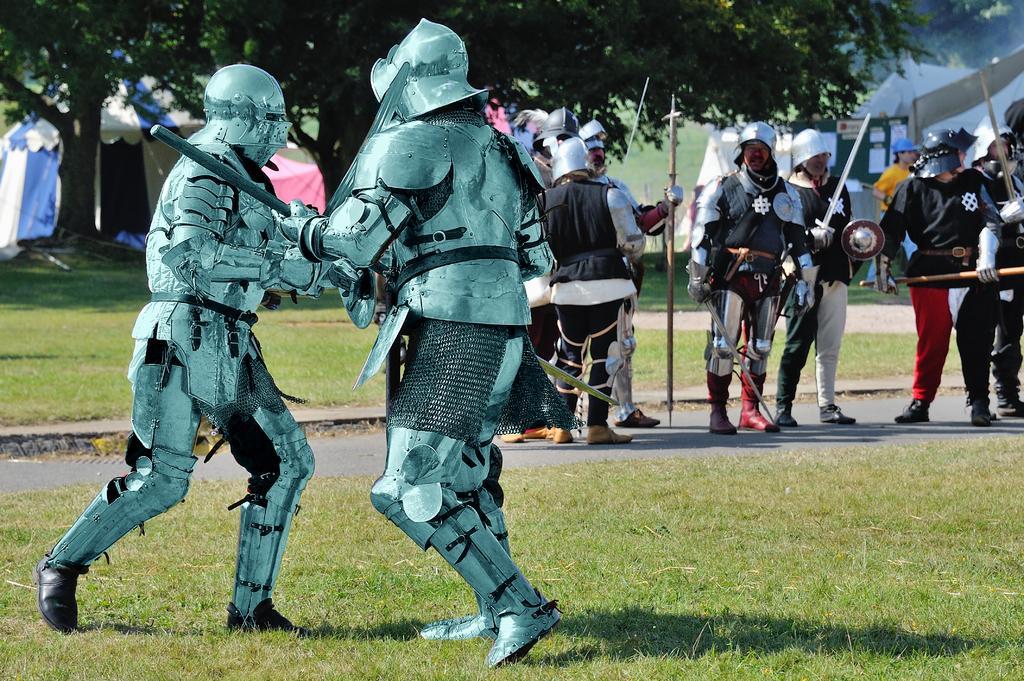In one or two sentences, can you explain what this image depicts? In this image we can see some group of persons, in the foreground of the image there are two persons wearing Armour dress fighting and in the background of the image there are some persons standing wearing similar dress holding some weapons in their hands, there are some trees, camping tents. 